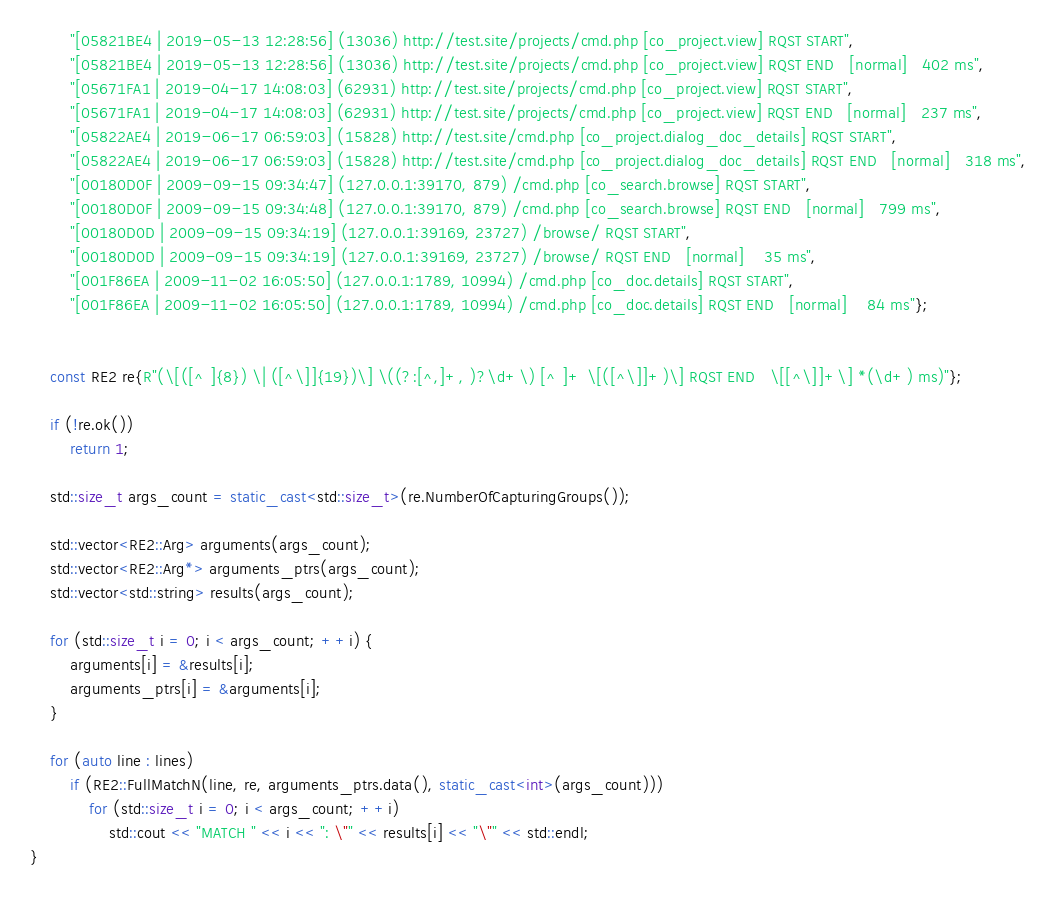Convert code to text. <code><loc_0><loc_0><loc_500><loc_500><_C++_>        "[05821BE4 | 2019-05-13 12:28:56] (13036) http://test.site/projects/cmd.php [co_project.view] RQST START",
        "[05821BE4 | 2019-05-13 12:28:56] (13036) http://test.site/projects/cmd.php [co_project.view] RQST END   [normal]   402 ms",
        "[05671FA1 | 2019-04-17 14:08:03] (62931) http://test.site/projects/cmd.php [co_project.view] RQST START",
        "[05671FA1 | 2019-04-17 14:08:03] (62931) http://test.site/projects/cmd.php [co_project.view] RQST END   [normal]   237 ms",
        "[05822AE4 | 2019-06-17 06:59:03] (15828) http://test.site/cmd.php [co_project.dialog_doc_details] RQST START",
        "[05822AE4 | 2019-06-17 06:59:03] (15828) http://test.site/cmd.php [co_project.dialog_doc_details] RQST END   [normal]   318 ms",
        "[00180D0F | 2009-09-15 09:34:47] (127.0.0.1:39170, 879) /cmd.php [co_search.browse] RQST START",
        "[00180D0F | 2009-09-15 09:34:48] (127.0.0.1:39170, 879) /cmd.php [co_search.browse] RQST END   [normal]   799 ms",
        "[00180D0D | 2009-09-15 09:34:19] (127.0.0.1:39169, 23727) /browse/ RQST START",
        "[00180D0D | 2009-09-15 09:34:19] (127.0.0.1:39169, 23727) /browse/ RQST END   [normal]    35 ms",
        "[001F86EA | 2009-11-02 16:05:50] (127.0.0.1:1789, 10994) /cmd.php [co_doc.details] RQST START",
        "[001F86EA | 2009-11-02 16:05:50] (127.0.0.1:1789, 10994) /cmd.php [co_doc.details] RQST END   [normal]    84 ms"};


    const RE2 re{R"(\[([^ ]{8}) \| ([^\]]{19})\] \((?:[^,]+, )?\d+\) [^ ]+ \[([^\]]+)\] RQST END   \[[^\]]+\] *(\d+) ms)"};

    if (!re.ok())
        return 1;

    std::size_t args_count = static_cast<std::size_t>(re.NumberOfCapturingGroups());

    std::vector<RE2::Arg> arguments(args_count);
    std::vector<RE2::Arg*> arguments_ptrs(args_count);
    std::vector<std::string> results(args_count);

    for (std::size_t i = 0; i < args_count; ++i) {
        arguments[i] = &results[i];
        arguments_ptrs[i] = &arguments[i];
    }

    for (auto line : lines)
        if (RE2::FullMatchN(line, re, arguments_ptrs.data(), static_cast<int>(args_count)))
            for (std::size_t i = 0; i < args_count; ++i)
                std::cout << "MATCH " << i << ": \"" << results[i] << "\"" << std::endl;
}
</code> 